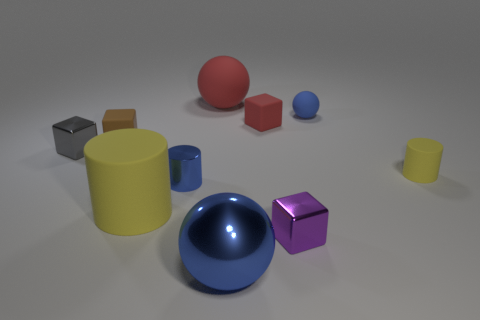Add 6 big rubber cylinders. How many big rubber cylinders are left? 7 Add 5 small yellow spheres. How many small yellow spheres exist? 5 Subtract all yellow cylinders. How many cylinders are left? 1 Subtract all yellow cylinders. How many cylinders are left? 1 Subtract 2 blue spheres. How many objects are left? 8 Subtract all cylinders. How many objects are left? 7 Subtract 2 blocks. How many blocks are left? 2 Subtract all yellow blocks. Subtract all purple cylinders. How many blocks are left? 4 Subtract all gray spheres. How many blue blocks are left? 0 Subtract all large brown shiny balls. Subtract all large blue metallic things. How many objects are left? 9 